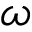Convert formula to latex. <formula><loc_0><loc_0><loc_500><loc_500>\omega</formula> 